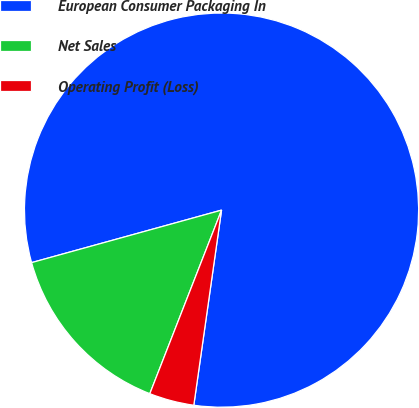Convert chart. <chart><loc_0><loc_0><loc_500><loc_500><pie_chart><fcel>European Consumer Packaging In<fcel>Net Sales<fcel>Operating Profit (Loss)<nl><fcel>81.54%<fcel>14.78%<fcel>3.68%<nl></chart> 